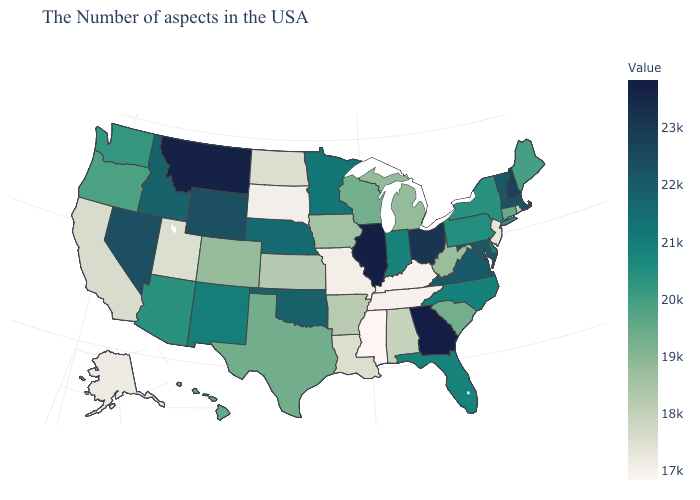Does Colorado have the lowest value in the USA?
Give a very brief answer. No. Which states have the lowest value in the USA?
Give a very brief answer. Mississippi. Which states have the lowest value in the USA?
Give a very brief answer. Mississippi. Does Maine have the lowest value in the USA?
Quick response, please. No. Which states have the lowest value in the USA?
Quick response, please. Mississippi. Does Georgia have the highest value in the USA?
Give a very brief answer. Yes. Which states have the highest value in the USA?
Answer briefly. Georgia. 